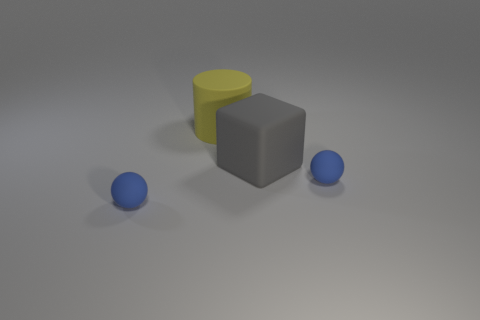Add 1 red blocks. How many objects exist? 5 Subtract all cylinders. How many objects are left? 3 Add 3 large gray matte cubes. How many large gray matte cubes are left? 4 Add 2 cyan blocks. How many cyan blocks exist? 2 Subtract 0 cyan balls. How many objects are left? 4 Subtract all purple matte objects. Subtract all large yellow matte things. How many objects are left? 3 